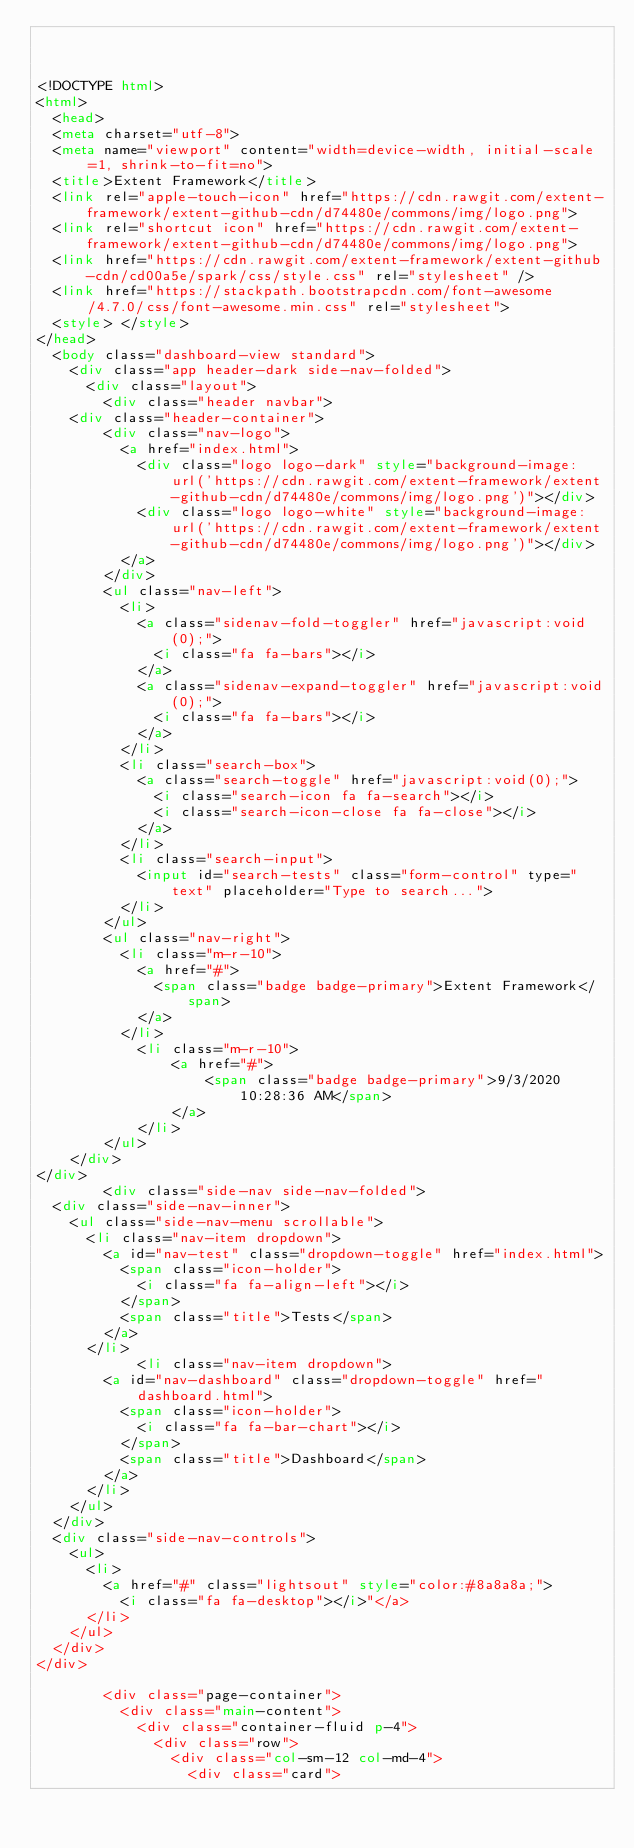Convert code to text. <code><loc_0><loc_0><loc_500><loc_500><_HTML_>


<!DOCTYPE html>
<html>
	<head>
  <meta charset="utf-8">
  <meta name="viewport" content="width=device-width, initial-scale=1, shrink-to-fit=no">
  <title>Extent Framework</title>
  <link rel="apple-touch-icon" href="https://cdn.rawgit.com/extent-framework/extent-github-cdn/d74480e/commons/img/logo.png">
  <link rel="shortcut icon" href="https://cdn.rawgit.com/extent-framework/extent-github-cdn/d74480e/commons/img/logo.png">
  <link href="https://cdn.rawgit.com/extent-framework/extent-github-cdn/cd00a5e/spark/css/style.css" rel="stylesheet" />
  <link href="https://stackpath.bootstrapcdn.com/font-awesome/4.7.0/css/font-awesome.min.css" rel="stylesheet">
  <style> </style>
</head>
	<body class="dashboard-view standard">
		<div class="app header-dark side-nav-folded">
			<div class="layout">
				<div class="header navbar">
    <div class="header-container">
        <div class="nav-logo">
          <a href="index.html">
            <div class="logo logo-dark" style="background-image: url('https://cdn.rawgit.com/extent-framework/extent-github-cdn/d74480e/commons/img/logo.png')"></div>
            <div class="logo logo-white" style="background-image: url('https://cdn.rawgit.com/extent-framework/extent-github-cdn/d74480e/commons/img/logo.png')"></div>
          </a>
        </div>
        <ul class="nav-left">
          <li>
            <a class="sidenav-fold-toggler" href="javascript:void(0);">
              <i class="fa fa-bars"></i>
            </a>
            <a class="sidenav-expand-toggler" href="javascript:void(0);">
              <i class="fa fa-bars"></i>
            </a>
          </li>
          <li class="search-box">
            <a class="search-toggle" href="javascript:void(0);">
              <i class="search-icon fa fa-search"></i>
              <i class="search-icon-close fa fa-close"></i>
            </a>
          </li>
          <li class="search-input">
            <input id="search-tests" class="form-control" type="text" placeholder="Type to search...">
          </li>
        </ul>
        <ul class="nav-right">
          <li class="m-r-10">
            <a href="#">
              <span class="badge badge-primary">Extent Framework</span>
            </a>
          </li>
            <li class="m-r-10">
                <a href="#">
                    <span class="badge badge-primary">9/3/2020 10:28:36 AM</span>
                </a>
            </li>
        </ul>
    </div>
</div>
				<div class="side-nav side-nav-folded">
  <div class="side-nav-inner">
    <ul class="side-nav-menu scrollable">
      <li class="nav-item dropdown">
        <a id="nav-test" class="dropdown-toggle" href="index.html">
          <span class="icon-holder">
            <i class="fa fa-align-left"></i>
          </span>
          <span class="title">Tests</span>
        </a>
      </li>
            <li class="nav-item dropdown">
        <a id="nav-dashboard" class="dropdown-toggle" href="dashboard.html">
          <span class="icon-holder">
            <i class="fa fa-bar-chart"></i>
          </span>
          <span class="title">Dashboard</span>
        </a>
      </li>
    </ul>
  </div>
  <div class="side-nav-controls">
    <ul>
      <li>
        <a href="#" class="lightsout" style="color:#8a8a8a;">
          <i class="fa fa-desktop"></i>"</a>
      </li>
    </ul>
  </div>
</div>

				<div class="page-container">
					<div class="main-content">
						<div class="container-fluid p-4">
							<div class="row">
								<div class="col-sm-12 col-md-4">
									<div class="card"></code> 